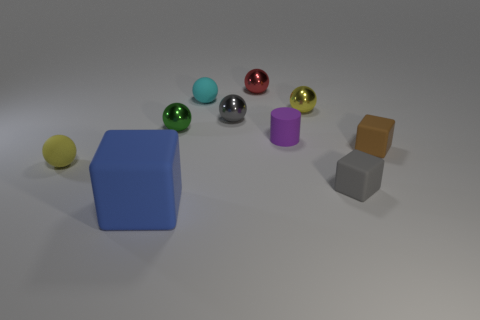Subtract 3 spheres. How many spheres are left? 3 Subtract all red balls. How many balls are left? 5 Subtract all tiny gray balls. How many balls are left? 5 Subtract all cyan spheres. Subtract all cyan cylinders. How many spheres are left? 5 Subtract all balls. How many objects are left? 4 Add 7 purple rubber cylinders. How many purple rubber cylinders exist? 8 Subtract 0 red blocks. How many objects are left? 10 Subtract all red cylinders. Subtract all small purple matte cylinders. How many objects are left? 9 Add 5 tiny yellow metal things. How many tiny yellow metal things are left? 6 